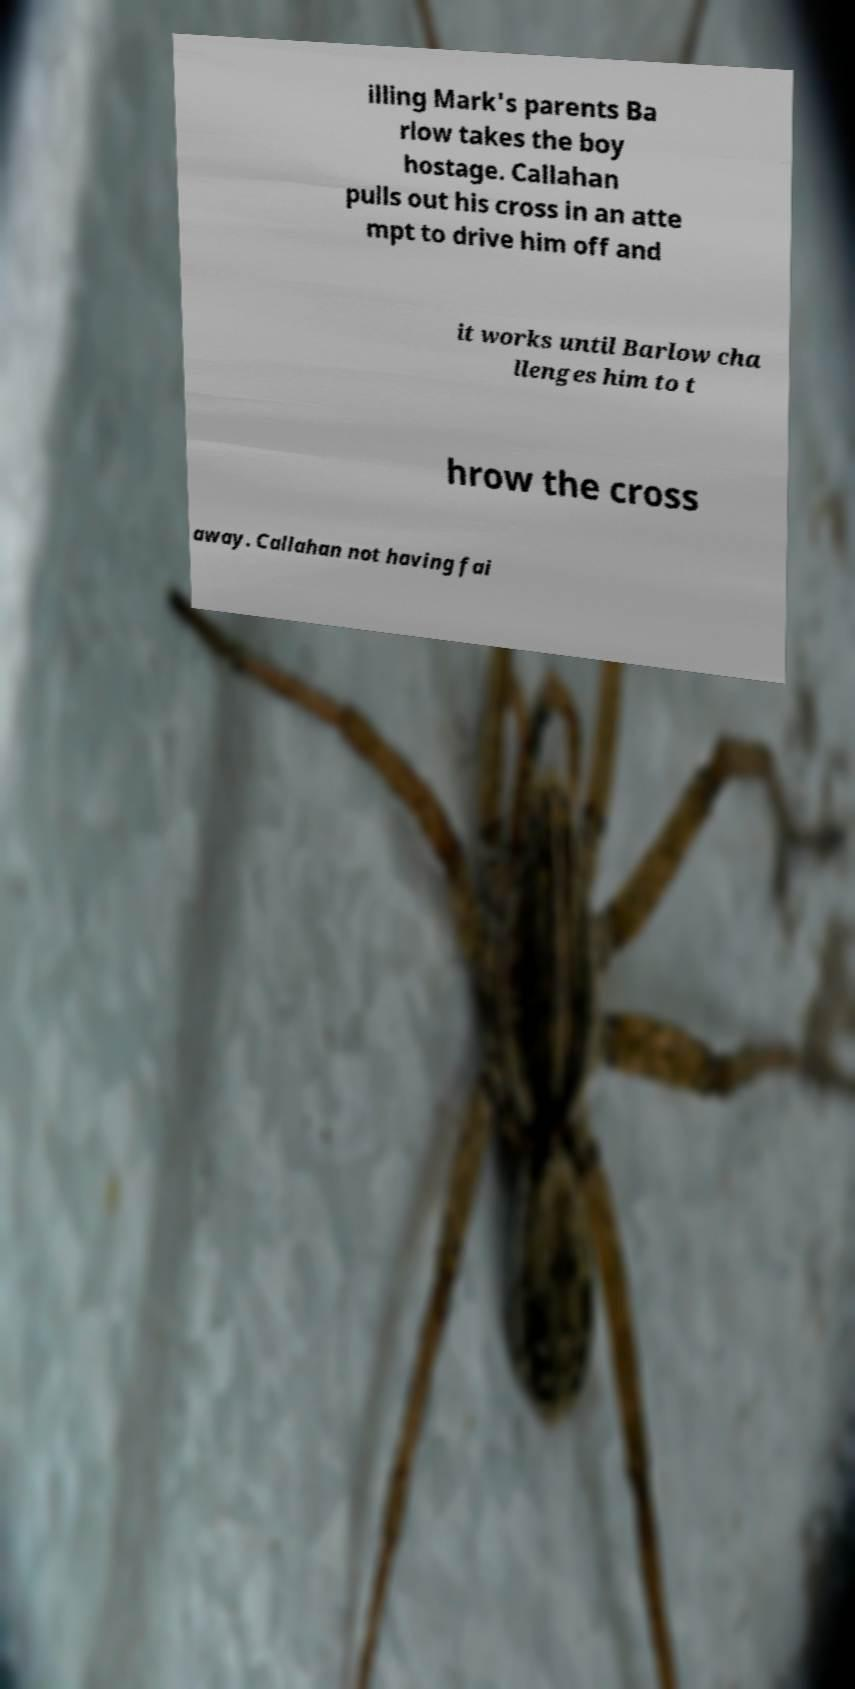Please identify and transcribe the text found in this image. illing Mark's parents Ba rlow takes the boy hostage. Callahan pulls out his cross in an atte mpt to drive him off and it works until Barlow cha llenges him to t hrow the cross away. Callahan not having fai 